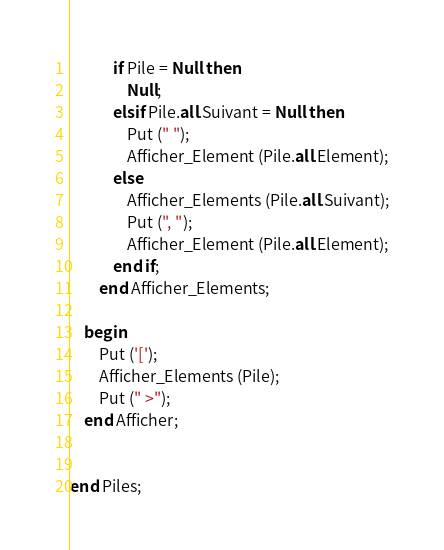Convert code to text. <code><loc_0><loc_0><loc_500><loc_500><_Ada_>			if Pile = Null then
				Null;
			elsif Pile.all.Suivant = Null then
				Put (" ");
				Afficher_Element (Pile.all.Element);
			else 
				Afficher_Elements (Pile.all.Suivant);
				Put (", ");
				Afficher_Element (Pile.all.Element);
			end if;
		end Afficher_Elements;

	begin
		Put ('[');
		Afficher_Elements (Pile);
		Put (" >");
	end Afficher;


end Piles;
</code> 